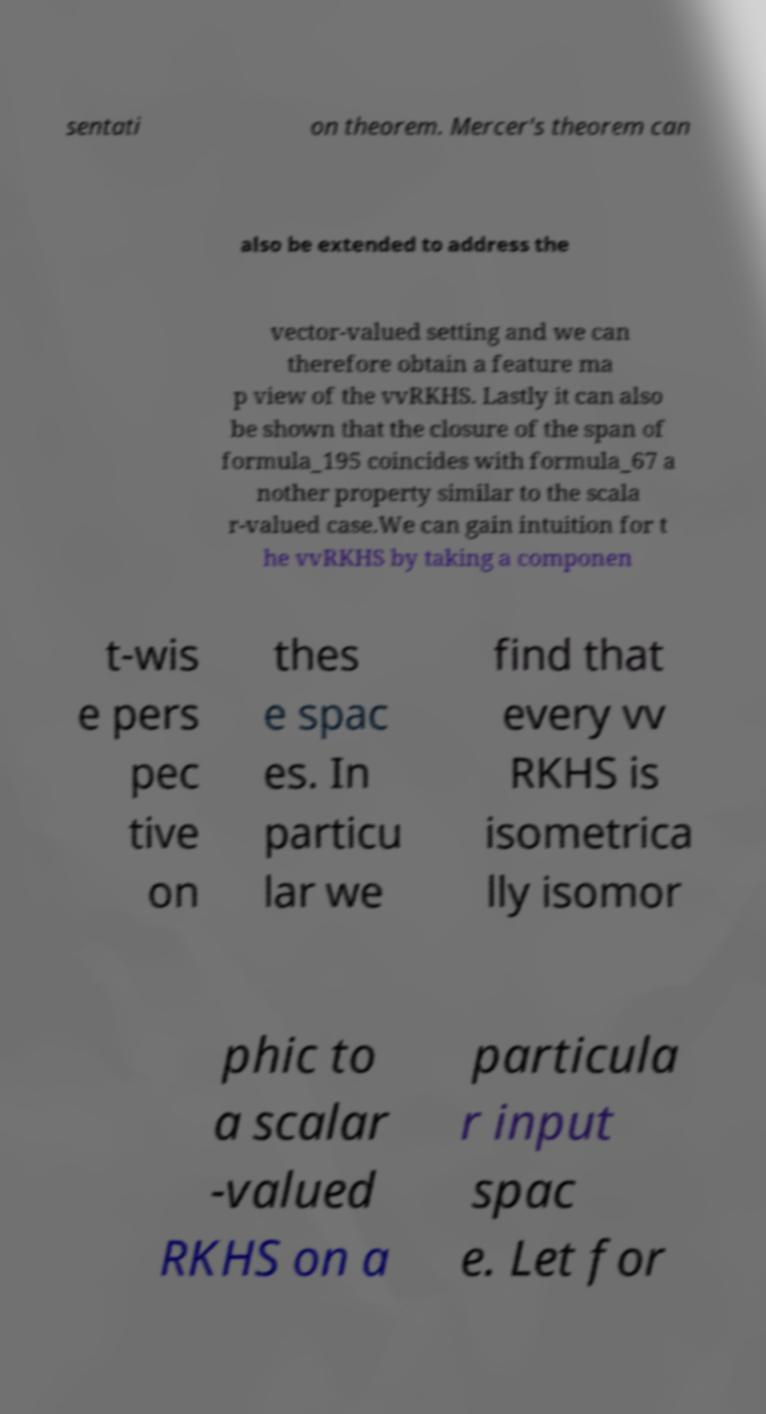Please identify and transcribe the text found in this image. sentati on theorem. Mercer's theorem can also be extended to address the vector-valued setting and we can therefore obtain a feature ma p view of the vvRKHS. Lastly it can also be shown that the closure of the span of formula_195 coincides with formula_67 a nother property similar to the scala r-valued case.We can gain intuition for t he vvRKHS by taking a componen t-wis e pers pec tive on thes e spac es. In particu lar we find that every vv RKHS is isometrica lly isomor phic to a scalar -valued RKHS on a particula r input spac e. Let for 